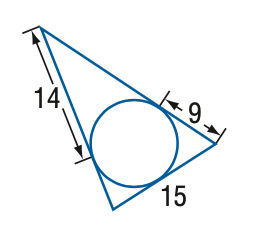Question: Find the perimeter of the triangle at the right. Assume that segments that appear to be tangent are tangent.
Choices:
A. 29
B. 38
C. 58
D. 76
Answer with the letter. Answer: C 